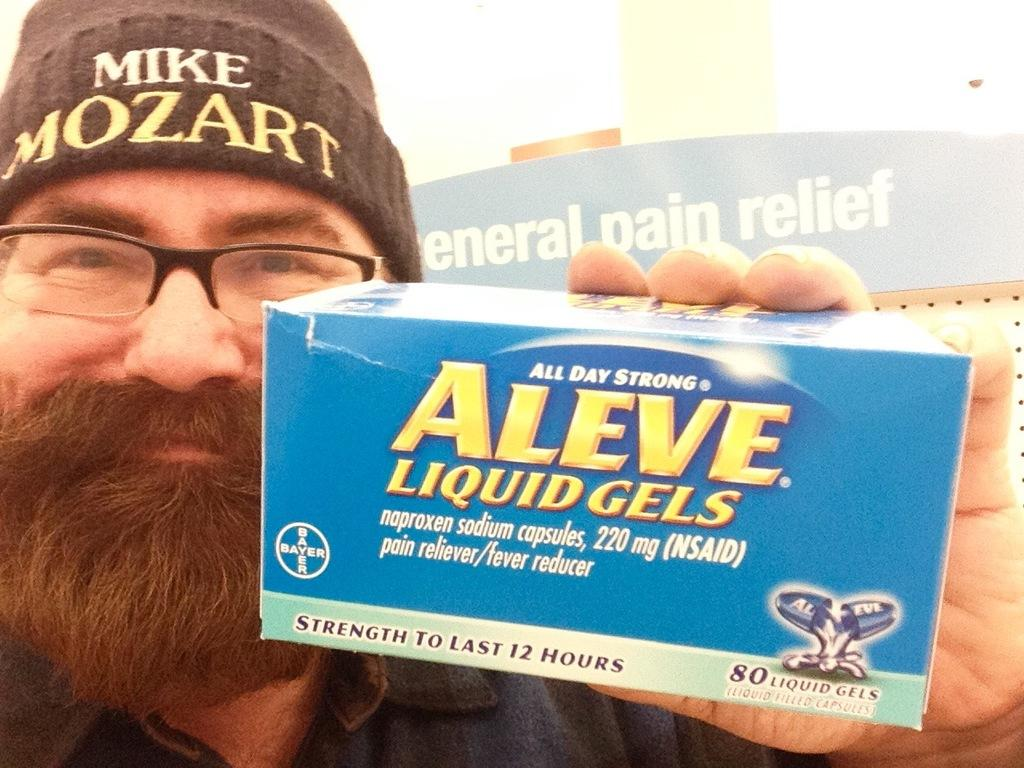What is the man in the image holding? The man is holding a medicine box in the image. What accessories is the man wearing in the image? The man is wearing a cap and spectacles in the image. What can be seen on the board in the image? There is a board with text in the image. What is visible in the background of the image? There is a building in the background of the image. What type of dirt can be seen on the man's shoes in the image? There is no dirt visible on the man's shoes in the image, as the facts provided do not mention any dirt or shoes. 